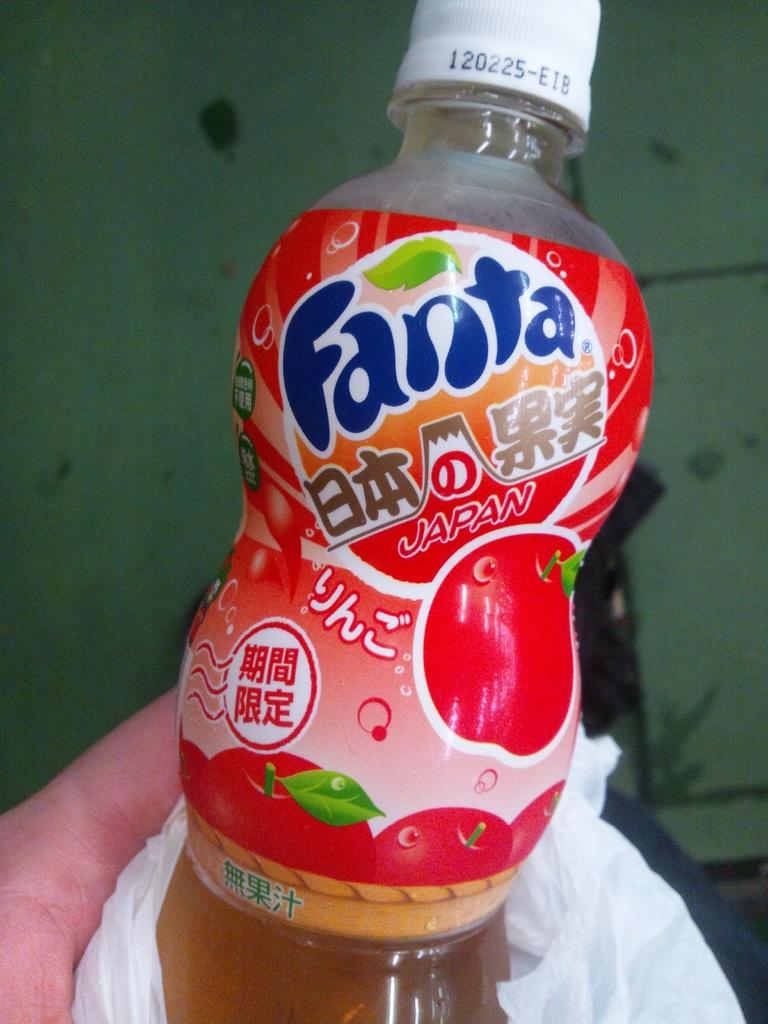<image>
Write a terse but informative summary of the picture. A person is holding a bottle of Fanta Japan. 